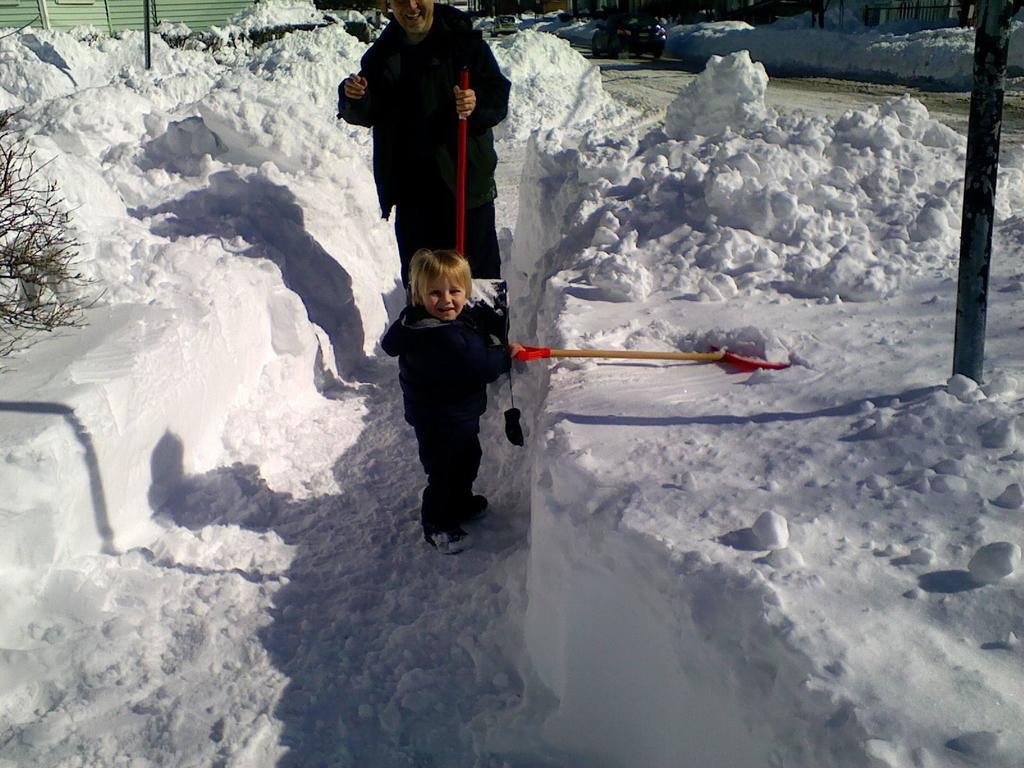Who is present in the image? There is a man and a kid in the image. What are the man and the kid holding in their hands? Both the man and the kid are holding sticks in their hands. What is the setting of the image? The scene takes place on a snowy land. What can be seen in the background of the image? There is a car visible in the background of the image, and it is on a road. Can you tell me how many friends the kid has in the image? There is no information about friends in the image; it only shows a man and a kid holding sticks. What type of credit card is the man using in the image? There is no credit card or any financial transaction depicted in the image. 